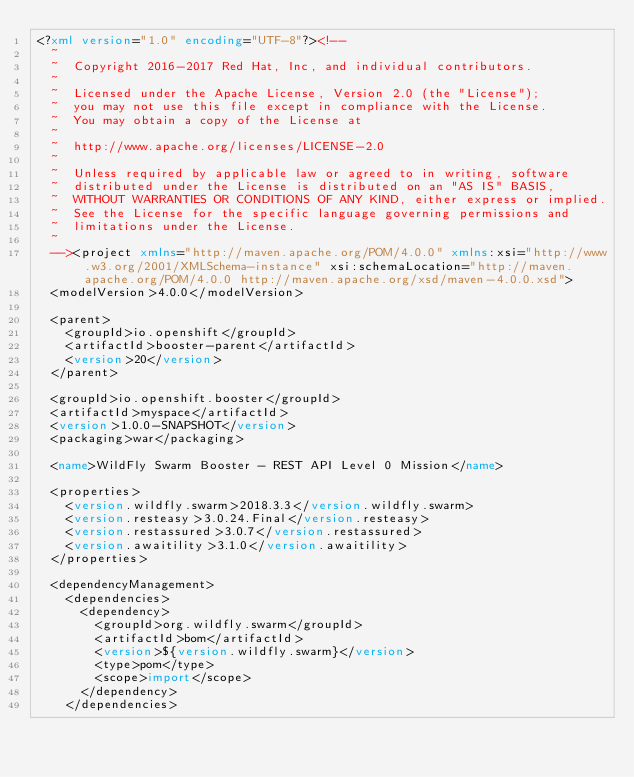Convert code to text. <code><loc_0><loc_0><loc_500><loc_500><_XML_><?xml version="1.0" encoding="UTF-8"?><!--
  ~
  ~  Copyright 2016-2017 Red Hat, Inc, and individual contributors.
  ~
  ~  Licensed under the Apache License, Version 2.0 (the "License");
  ~  you may not use this file except in compliance with the License.
  ~  You may obtain a copy of the License at
  ~
  ~  http://www.apache.org/licenses/LICENSE-2.0
  ~
  ~  Unless required by applicable law or agreed to in writing, software
  ~  distributed under the License is distributed on an "AS IS" BASIS,
  ~  WITHOUT WARRANTIES OR CONDITIONS OF ANY KIND, either express or implied.
  ~  See the License for the specific language governing permissions and
  ~  limitations under the License.
  ~
  --><project xmlns="http://maven.apache.org/POM/4.0.0" xmlns:xsi="http://www.w3.org/2001/XMLSchema-instance" xsi:schemaLocation="http://maven.apache.org/POM/4.0.0 http://maven.apache.org/xsd/maven-4.0.0.xsd">
  <modelVersion>4.0.0</modelVersion>

  <parent>
    <groupId>io.openshift</groupId>
    <artifactId>booster-parent</artifactId>
    <version>20</version>
  </parent>

  <groupId>io.openshift.booster</groupId>
  <artifactId>myspace</artifactId>
  <version>1.0.0-SNAPSHOT</version>
  <packaging>war</packaging>

  <name>WildFly Swarm Booster - REST API Level 0 Mission</name>

  <properties>
    <version.wildfly.swarm>2018.3.3</version.wildfly.swarm>
    <version.resteasy>3.0.24.Final</version.resteasy>
    <version.restassured>3.0.7</version.restassured>
    <version.awaitility>3.1.0</version.awaitility>
  </properties>

  <dependencyManagement>
    <dependencies>
      <dependency>
        <groupId>org.wildfly.swarm</groupId>
        <artifactId>bom</artifactId>
        <version>${version.wildfly.swarm}</version>
        <type>pom</type>
        <scope>import</scope>
      </dependency>
    </dependencies></code> 